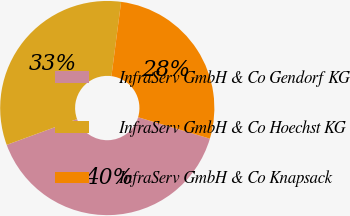Convert chart. <chart><loc_0><loc_0><loc_500><loc_500><pie_chart><fcel>InfraServ GmbH & Co Gendorf KG<fcel>InfraServ GmbH & Co Hoechst KG<fcel>InfraServ GmbH & Co Knapsack<nl><fcel>39.8%<fcel>32.65%<fcel>27.55%<nl></chart> 